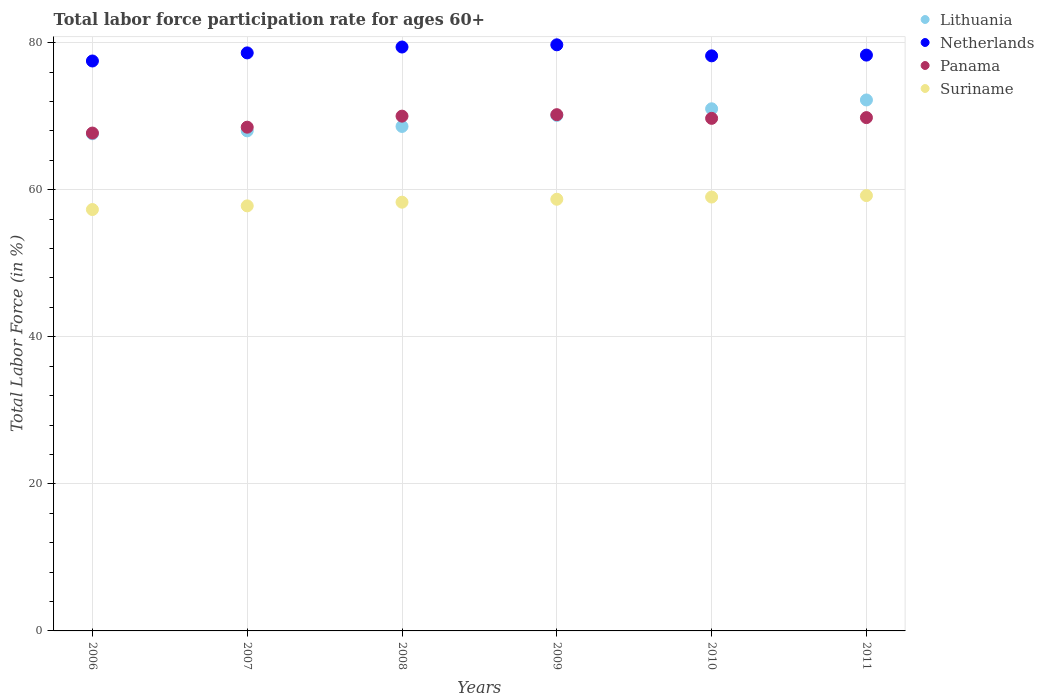How many different coloured dotlines are there?
Your response must be concise. 4. What is the labor force participation rate in Lithuania in 2008?
Offer a very short reply. 68.6. Across all years, what is the maximum labor force participation rate in Panama?
Provide a succinct answer. 70.2. Across all years, what is the minimum labor force participation rate in Lithuania?
Provide a succinct answer. 67.6. In which year was the labor force participation rate in Lithuania maximum?
Your response must be concise. 2011. What is the total labor force participation rate in Suriname in the graph?
Keep it short and to the point. 350.3. What is the difference between the labor force participation rate in Lithuania in 2006 and that in 2011?
Give a very brief answer. -4.6. What is the difference between the labor force participation rate in Panama in 2011 and the labor force participation rate in Netherlands in 2009?
Provide a succinct answer. -9.9. What is the average labor force participation rate in Lithuania per year?
Your answer should be compact. 69.58. In the year 2009, what is the difference between the labor force participation rate in Netherlands and labor force participation rate in Suriname?
Ensure brevity in your answer.  21. In how many years, is the labor force participation rate in Lithuania greater than 8 %?
Your answer should be very brief. 6. What is the ratio of the labor force participation rate in Lithuania in 2009 to that in 2011?
Give a very brief answer. 0.97. Is the labor force participation rate in Netherlands in 2007 less than that in 2009?
Your answer should be very brief. Yes. Is the difference between the labor force participation rate in Netherlands in 2007 and 2009 greater than the difference between the labor force participation rate in Suriname in 2007 and 2009?
Give a very brief answer. No. What is the difference between the highest and the second highest labor force participation rate in Suriname?
Make the answer very short. 0.2. What is the difference between the highest and the lowest labor force participation rate in Lithuania?
Offer a terse response. 4.6. In how many years, is the labor force participation rate in Netherlands greater than the average labor force participation rate in Netherlands taken over all years?
Make the answer very short. 2. Is it the case that in every year, the sum of the labor force participation rate in Netherlands and labor force participation rate in Lithuania  is greater than the labor force participation rate in Suriname?
Your answer should be very brief. Yes. Does the labor force participation rate in Suriname monotonically increase over the years?
Ensure brevity in your answer.  Yes. Is the labor force participation rate in Lithuania strictly less than the labor force participation rate in Suriname over the years?
Your answer should be compact. No. How many dotlines are there?
Make the answer very short. 4. How many legend labels are there?
Your response must be concise. 4. How are the legend labels stacked?
Give a very brief answer. Vertical. What is the title of the graph?
Keep it short and to the point. Total labor force participation rate for ages 60+. Does "Thailand" appear as one of the legend labels in the graph?
Offer a very short reply. No. What is the label or title of the Y-axis?
Make the answer very short. Total Labor Force (in %). What is the Total Labor Force (in %) in Lithuania in 2006?
Offer a terse response. 67.6. What is the Total Labor Force (in %) of Netherlands in 2006?
Your response must be concise. 77.5. What is the Total Labor Force (in %) of Panama in 2006?
Make the answer very short. 67.7. What is the Total Labor Force (in %) in Suriname in 2006?
Offer a terse response. 57.3. What is the Total Labor Force (in %) in Netherlands in 2007?
Offer a very short reply. 78.6. What is the Total Labor Force (in %) of Panama in 2007?
Offer a terse response. 68.5. What is the Total Labor Force (in %) in Suriname in 2007?
Ensure brevity in your answer.  57.8. What is the Total Labor Force (in %) in Lithuania in 2008?
Offer a very short reply. 68.6. What is the Total Labor Force (in %) in Netherlands in 2008?
Provide a short and direct response. 79.4. What is the Total Labor Force (in %) of Suriname in 2008?
Provide a succinct answer. 58.3. What is the Total Labor Force (in %) of Lithuania in 2009?
Your answer should be very brief. 70.1. What is the Total Labor Force (in %) in Netherlands in 2009?
Ensure brevity in your answer.  79.7. What is the Total Labor Force (in %) of Panama in 2009?
Provide a succinct answer. 70.2. What is the Total Labor Force (in %) in Suriname in 2009?
Keep it short and to the point. 58.7. What is the Total Labor Force (in %) in Lithuania in 2010?
Your answer should be very brief. 71. What is the Total Labor Force (in %) of Netherlands in 2010?
Provide a succinct answer. 78.2. What is the Total Labor Force (in %) of Panama in 2010?
Offer a very short reply. 69.7. What is the Total Labor Force (in %) in Suriname in 2010?
Your answer should be very brief. 59. What is the Total Labor Force (in %) in Lithuania in 2011?
Offer a terse response. 72.2. What is the Total Labor Force (in %) in Netherlands in 2011?
Give a very brief answer. 78.3. What is the Total Labor Force (in %) in Panama in 2011?
Your response must be concise. 69.8. What is the Total Labor Force (in %) of Suriname in 2011?
Offer a very short reply. 59.2. Across all years, what is the maximum Total Labor Force (in %) in Lithuania?
Keep it short and to the point. 72.2. Across all years, what is the maximum Total Labor Force (in %) of Netherlands?
Your answer should be compact. 79.7. Across all years, what is the maximum Total Labor Force (in %) in Panama?
Offer a very short reply. 70.2. Across all years, what is the maximum Total Labor Force (in %) of Suriname?
Keep it short and to the point. 59.2. Across all years, what is the minimum Total Labor Force (in %) of Lithuania?
Your response must be concise. 67.6. Across all years, what is the minimum Total Labor Force (in %) in Netherlands?
Provide a short and direct response. 77.5. Across all years, what is the minimum Total Labor Force (in %) in Panama?
Keep it short and to the point. 67.7. Across all years, what is the minimum Total Labor Force (in %) in Suriname?
Offer a terse response. 57.3. What is the total Total Labor Force (in %) of Lithuania in the graph?
Your response must be concise. 417.5. What is the total Total Labor Force (in %) of Netherlands in the graph?
Make the answer very short. 471.7. What is the total Total Labor Force (in %) of Panama in the graph?
Make the answer very short. 415.9. What is the total Total Labor Force (in %) in Suriname in the graph?
Keep it short and to the point. 350.3. What is the difference between the Total Labor Force (in %) of Lithuania in 2006 and that in 2007?
Give a very brief answer. -0.4. What is the difference between the Total Labor Force (in %) in Netherlands in 2006 and that in 2007?
Offer a very short reply. -1.1. What is the difference between the Total Labor Force (in %) of Panama in 2006 and that in 2007?
Offer a terse response. -0.8. What is the difference between the Total Labor Force (in %) of Lithuania in 2006 and that in 2008?
Provide a short and direct response. -1. What is the difference between the Total Labor Force (in %) of Netherlands in 2006 and that in 2008?
Give a very brief answer. -1.9. What is the difference between the Total Labor Force (in %) in Panama in 2006 and that in 2008?
Give a very brief answer. -2.3. What is the difference between the Total Labor Force (in %) in Lithuania in 2006 and that in 2009?
Offer a terse response. -2.5. What is the difference between the Total Labor Force (in %) in Panama in 2006 and that in 2010?
Keep it short and to the point. -2. What is the difference between the Total Labor Force (in %) of Lithuania in 2006 and that in 2011?
Your answer should be compact. -4.6. What is the difference between the Total Labor Force (in %) in Netherlands in 2006 and that in 2011?
Provide a succinct answer. -0.8. What is the difference between the Total Labor Force (in %) in Suriname in 2006 and that in 2011?
Make the answer very short. -1.9. What is the difference between the Total Labor Force (in %) in Netherlands in 2007 and that in 2008?
Provide a succinct answer. -0.8. What is the difference between the Total Labor Force (in %) of Lithuania in 2007 and that in 2009?
Ensure brevity in your answer.  -2.1. What is the difference between the Total Labor Force (in %) of Panama in 2007 and that in 2009?
Provide a short and direct response. -1.7. What is the difference between the Total Labor Force (in %) of Lithuania in 2007 and that in 2010?
Provide a succinct answer. -3. What is the difference between the Total Labor Force (in %) of Panama in 2007 and that in 2011?
Your answer should be very brief. -1.3. What is the difference between the Total Labor Force (in %) in Panama in 2008 and that in 2009?
Your answer should be compact. -0.2. What is the difference between the Total Labor Force (in %) of Suriname in 2008 and that in 2009?
Your answer should be very brief. -0.4. What is the difference between the Total Labor Force (in %) in Lithuania in 2008 and that in 2010?
Make the answer very short. -2.4. What is the difference between the Total Labor Force (in %) in Netherlands in 2008 and that in 2010?
Provide a succinct answer. 1.2. What is the difference between the Total Labor Force (in %) in Suriname in 2008 and that in 2010?
Ensure brevity in your answer.  -0.7. What is the difference between the Total Labor Force (in %) in Lithuania in 2008 and that in 2011?
Give a very brief answer. -3.6. What is the difference between the Total Labor Force (in %) in Netherlands in 2008 and that in 2011?
Offer a terse response. 1.1. What is the difference between the Total Labor Force (in %) in Panama in 2008 and that in 2011?
Give a very brief answer. 0.2. What is the difference between the Total Labor Force (in %) in Panama in 2009 and that in 2010?
Your answer should be very brief. 0.5. What is the difference between the Total Labor Force (in %) in Netherlands in 2009 and that in 2011?
Offer a terse response. 1.4. What is the difference between the Total Labor Force (in %) in Panama in 2009 and that in 2011?
Provide a succinct answer. 0.4. What is the difference between the Total Labor Force (in %) in Suriname in 2009 and that in 2011?
Provide a short and direct response. -0.5. What is the difference between the Total Labor Force (in %) of Lithuania in 2010 and that in 2011?
Make the answer very short. -1.2. What is the difference between the Total Labor Force (in %) in Panama in 2010 and that in 2011?
Ensure brevity in your answer.  -0.1. What is the difference between the Total Labor Force (in %) in Lithuania in 2006 and the Total Labor Force (in %) in Suriname in 2007?
Provide a succinct answer. 9.8. What is the difference between the Total Labor Force (in %) of Panama in 2006 and the Total Labor Force (in %) of Suriname in 2007?
Make the answer very short. 9.9. What is the difference between the Total Labor Force (in %) in Lithuania in 2006 and the Total Labor Force (in %) in Netherlands in 2008?
Your answer should be very brief. -11.8. What is the difference between the Total Labor Force (in %) in Panama in 2006 and the Total Labor Force (in %) in Suriname in 2008?
Keep it short and to the point. 9.4. What is the difference between the Total Labor Force (in %) of Lithuania in 2006 and the Total Labor Force (in %) of Netherlands in 2009?
Make the answer very short. -12.1. What is the difference between the Total Labor Force (in %) in Lithuania in 2006 and the Total Labor Force (in %) in Panama in 2009?
Offer a terse response. -2.6. What is the difference between the Total Labor Force (in %) of Lithuania in 2006 and the Total Labor Force (in %) of Suriname in 2009?
Ensure brevity in your answer.  8.9. What is the difference between the Total Labor Force (in %) in Panama in 2006 and the Total Labor Force (in %) in Suriname in 2009?
Your answer should be very brief. 9. What is the difference between the Total Labor Force (in %) in Lithuania in 2006 and the Total Labor Force (in %) in Panama in 2010?
Give a very brief answer. -2.1. What is the difference between the Total Labor Force (in %) in Netherlands in 2006 and the Total Labor Force (in %) in Panama in 2010?
Provide a short and direct response. 7.8. What is the difference between the Total Labor Force (in %) of Panama in 2006 and the Total Labor Force (in %) of Suriname in 2010?
Offer a terse response. 8.7. What is the difference between the Total Labor Force (in %) in Lithuania in 2006 and the Total Labor Force (in %) in Netherlands in 2011?
Offer a terse response. -10.7. What is the difference between the Total Labor Force (in %) in Lithuania in 2006 and the Total Labor Force (in %) in Panama in 2011?
Your response must be concise. -2.2. What is the difference between the Total Labor Force (in %) of Netherlands in 2006 and the Total Labor Force (in %) of Panama in 2011?
Your response must be concise. 7.7. What is the difference between the Total Labor Force (in %) of Panama in 2006 and the Total Labor Force (in %) of Suriname in 2011?
Your answer should be compact. 8.5. What is the difference between the Total Labor Force (in %) in Netherlands in 2007 and the Total Labor Force (in %) in Panama in 2008?
Make the answer very short. 8.6. What is the difference between the Total Labor Force (in %) in Netherlands in 2007 and the Total Labor Force (in %) in Suriname in 2008?
Keep it short and to the point. 20.3. What is the difference between the Total Labor Force (in %) of Lithuania in 2007 and the Total Labor Force (in %) of Panama in 2009?
Keep it short and to the point. -2.2. What is the difference between the Total Labor Force (in %) in Lithuania in 2007 and the Total Labor Force (in %) in Suriname in 2009?
Your response must be concise. 9.3. What is the difference between the Total Labor Force (in %) in Panama in 2007 and the Total Labor Force (in %) in Suriname in 2009?
Provide a succinct answer. 9.8. What is the difference between the Total Labor Force (in %) in Lithuania in 2007 and the Total Labor Force (in %) in Panama in 2010?
Offer a terse response. -1.7. What is the difference between the Total Labor Force (in %) in Netherlands in 2007 and the Total Labor Force (in %) in Suriname in 2010?
Give a very brief answer. 19.6. What is the difference between the Total Labor Force (in %) in Panama in 2007 and the Total Labor Force (in %) in Suriname in 2010?
Offer a very short reply. 9.5. What is the difference between the Total Labor Force (in %) in Lithuania in 2007 and the Total Labor Force (in %) in Netherlands in 2011?
Your answer should be compact. -10.3. What is the difference between the Total Labor Force (in %) of Lithuania in 2007 and the Total Labor Force (in %) of Panama in 2011?
Ensure brevity in your answer.  -1.8. What is the difference between the Total Labor Force (in %) of Lithuania in 2007 and the Total Labor Force (in %) of Suriname in 2011?
Give a very brief answer. 8.8. What is the difference between the Total Labor Force (in %) of Panama in 2007 and the Total Labor Force (in %) of Suriname in 2011?
Provide a short and direct response. 9.3. What is the difference between the Total Labor Force (in %) in Lithuania in 2008 and the Total Labor Force (in %) in Netherlands in 2009?
Make the answer very short. -11.1. What is the difference between the Total Labor Force (in %) in Netherlands in 2008 and the Total Labor Force (in %) in Panama in 2009?
Keep it short and to the point. 9.2. What is the difference between the Total Labor Force (in %) in Netherlands in 2008 and the Total Labor Force (in %) in Suriname in 2009?
Offer a very short reply. 20.7. What is the difference between the Total Labor Force (in %) in Panama in 2008 and the Total Labor Force (in %) in Suriname in 2009?
Offer a terse response. 11.3. What is the difference between the Total Labor Force (in %) in Lithuania in 2008 and the Total Labor Force (in %) in Panama in 2010?
Ensure brevity in your answer.  -1.1. What is the difference between the Total Labor Force (in %) of Lithuania in 2008 and the Total Labor Force (in %) of Suriname in 2010?
Offer a very short reply. 9.6. What is the difference between the Total Labor Force (in %) of Netherlands in 2008 and the Total Labor Force (in %) of Suriname in 2010?
Provide a short and direct response. 20.4. What is the difference between the Total Labor Force (in %) in Netherlands in 2008 and the Total Labor Force (in %) in Suriname in 2011?
Make the answer very short. 20.2. What is the difference between the Total Labor Force (in %) in Panama in 2008 and the Total Labor Force (in %) in Suriname in 2011?
Offer a terse response. 10.8. What is the difference between the Total Labor Force (in %) of Lithuania in 2009 and the Total Labor Force (in %) of Panama in 2010?
Offer a very short reply. 0.4. What is the difference between the Total Labor Force (in %) in Lithuania in 2009 and the Total Labor Force (in %) in Suriname in 2010?
Give a very brief answer. 11.1. What is the difference between the Total Labor Force (in %) of Netherlands in 2009 and the Total Labor Force (in %) of Panama in 2010?
Make the answer very short. 10. What is the difference between the Total Labor Force (in %) of Netherlands in 2009 and the Total Labor Force (in %) of Suriname in 2010?
Make the answer very short. 20.7. What is the difference between the Total Labor Force (in %) in Lithuania in 2009 and the Total Labor Force (in %) in Netherlands in 2011?
Ensure brevity in your answer.  -8.2. What is the difference between the Total Labor Force (in %) in Lithuania in 2010 and the Total Labor Force (in %) in Netherlands in 2011?
Keep it short and to the point. -7.3. What is the difference between the Total Labor Force (in %) in Lithuania in 2010 and the Total Labor Force (in %) in Panama in 2011?
Give a very brief answer. 1.2. What is the difference between the Total Labor Force (in %) in Netherlands in 2010 and the Total Labor Force (in %) in Panama in 2011?
Your answer should be very brief. 8.4. What is the difference between the Total Labor Force (in %) of Netherlands in 2010 and the Total Labor Force (in %) of Suriname in 2011?
Ensure brevity in your answer.  19. What is the difference between the Total Labor Force (in %) of Panama in 2010 and the Total Labor Force (in %) of Suriname in 2011?
Your response must be concise. 10.5. What is the average Total Labor Force (in %) of Lithuania per year?
Your response must be concise. 69.58. What is the average Total Labor Force (in %) in Netherlands per year?
Keep it short and to the point. 78.62. What is the average Total Labor Force (in %) of Panama per year?
Provide a short and direct response. 69.32. What is the average Total Labor Force (in %) in Suriname per year?
Provide a succinct answer. 58.38. In the year 2006, what is the difference between the Total Labor Force (in %) of Lithuania and Total Labor Force (in %) of Panama?
Offer a very short reply. -0.1. In the year 2006, what is the difference between the Total Labor Force (in %) of Lithuania and Total Labor Force (in %) of Suriname?
Provide a short and direct response. 10.3. In the year 2006, what is the difference between the Total Labor Force (in %) in Netherlands and Total Labor Force (in %) in Panama?
Your answer should be very brief. 9.8. In the year 2006, what is the difference between the Total Labor Force (in %) of Netherlands and Total Labor Force (in %) of Suriname?
Your answer should be very brief. 20.2. In the year 2007, what is the difference between the Total Labor Force (in %) in Lithuania and Total Labor Force (in %) in Netherlands?
Your answer should be compact. -10.6. In the year 2007, what is the difference between the Total Labor Force (in %) of Netherlands and Total Labor Force (in %) of Suriname?
Your answer should be very brief. 20.8. In the year 2007, what is the difference between the Total Labor Force (in %) of Panama and Total Labor Force (in %) of Suriname?
Give a very brief answer. 10.7. In the year 2008, what is the difference between the Total Labor Force (in %) in Lithuania and Total Labor Force (in %) in Netherlands?
Your response must be concise. -10.8. In the year 2008, what is the difference between the Total Labor Force (in %) of Netherlands and Total Labor Force (in %) of Suriname?
Provide a succinct answer. 21.1. In the year 2009, what is the difference between the Total Labor Force (in %) of Lithuania and Total Labor Force (in %) of Netherlands?
Provide a succinct answer. -9.6. In the year 2009, what is the difference between the Total Labor Force (in %) in Netherlands and Total Labor Force (in %) in Suriname?
Your response must be concise. 21. In the year 2010, what is the difference between the Total Labor Force (in %) of Lithuania and Total Labor Force (in %) of Suriname?
Offer a very short reply. 12. In the year 2010, what is the difference between the Total Labor Force (in %) in Netherlands and Total Labor Force (in %) in Panama?
Make the answer very short. 8.5. In the year 2010, what is the difference between the Total Labor Force (in %) of Panama and Total Labor Force (in %) of Suriname?
Make the answer very short. 10.7. In the year 2011, what is the difference between the Total Labor Force (in %) of Lithuania and Total Labor Force (in %) of Panama?
Provide a short and direct response. 2.4. In the year 2011, what is the difference between the Total Labor Force (in %) of Netherlands and Total Labor Force (in %) of Suriname?
Ensure brevity in your answer.  19.1. In the year 2011, what is the difference between the Total Labor Force (in %) in Panama and Total Labor Force (in %) in Suriname?
Provide a succinct answer. 10.6. What is the ratio of the Total Labor Force (in %) of Lithuania in 2006 to that in 2007?
Make the answer very short. 0.99. What is the ratio of the Total Labor Force (in %) of Netherlands in 2006 to that in 2007?
Provide a short and direct response. 0.99. What is the ratio of the Total Labor Force (in %) of Panama in 2006 to that in 2007?
Offer a very short reply. 0.99. What is the ratio of the Total Labor Force (in %) of Suriname in 2006 to that in 2007?
Provide a succinct answer. 0.99. What is the ratio of the Total Labor Force (in %) in Lithuania in 2006 to that in 2008?
Make the answer very short. 0.99. What is the ratio of the Total Labor Force (in %) of Netherlands in 2006 to that in 2008?
Offer a terse response. 0.98. What is the ratio of the Total Labor Force (in %) in Panama in 2006 to that in 2008?
Your answer should be compact. 0.97. What is the ratio of the Total Labor Force (in %) of Suriname in 2006 to that in 2008?
Keep it short and to the point. 0.98. What is the ratio of the Total Labor Force (in %) in Lithuania in 2006 to that in 2009?
Keep it short and to the point. 0.96. What is the ratio of the Total Labor Force (in %) of Netherlands in 2006 to that in 2009?
Keep it short and to the point. 0.97. What is the ratio of the Total Labor Force (in %) in Panama in 2006 to that in 2009?
Give a very brief answer. 0.96. What is the ratio of the Total Labor Force (in %) of Suriname in 2006 to that in 2009?
Offer a terse response. 0.98. What is the ratio of the Total Labor Force (in %) in Lithuania in 2006 to that in 2010?
Offer a terse response. 0.95. What is the ratio of the Total Labor Force (in %) of Netherlands in 2006 to that in 2010?
Provide a short and direct response. 0.99. What is the ratio of the Total Labor Force (in %) in Panama in 2006 to that in 2010?
Your response must be concise. 0.97. What is the ratio of the Total Labor Force (in %) of Suriname in 2006 to that in 2010?
Your response must be concise. 0.97. What is the ratio of the Total Labor Force (in %) in Lithuania in 2006 to that in 2011?
Provide a succinct answer. 0.94. What is the ratio of the Total Labor Force (in %) of Netherlands in 2006 to that in 2011?
Provide a succinct answer. 0.99. What is the ratio of the Total Labor Force (in %) in Panama in 2006 to that in 2011?
Give a very brief answer. 0.97. What is the ratio of the Total Labor Force (in %) in Suriname in 2006 to that in 2011?
Offer a terse response. 0.97. What is the ratio of the Total Labor Force (in %) of Netherlands in 2007 to that in 2008?
Offer a terse response. 0.99. What is the ratio of the Total Labor Force (in %) in Panama in 2007 to that in 2008?
Your answer should be very brief. 0.98. What is the ratio of the Total Labor Force (in %) of Suriname in 2007 to that in 2008?
Your answer should be compact. 0.99. What is the ratio of the Total Labor Force (in %) of Netherlands in 2007 to that in 2009?
Offer a very short reply. 0.99. What is the ratio of the Total Labor Force (in %) in Panama in 2007 to that in 2009?
Provide a short and direct response. 0.98. What is the ratio of the Total Labor Force (in %) of Suriname in 2007 to that in 2009?
Your answer should be compact. 0.98. What is the ratio of the Total Labor Force (in %) of Lithuania in 2007 to that in 2010?
Make the answer very short. 0.96. What is the ratio of the Total Labor Force (in %) of Panama in 2007 to that in 2010?
Give a very brief answer. 0.98. What is the ratio of the Total Labor Force (in %) of Suriname in 2007 to that in 2010?
Your response must be concise. 0.98. What is the ratio of the Total Labor Force (in %) of Lithuania in 2007 to that in 2011?
Offer a terse response. 0.94. What is the ratio of the Total Labor Force (in %) in Panama in 2007 to that in 2011?
Keep it short and to the point. 0.98. What is the ratio of the Total Labor Force (in %) in Suriname in 2007 to that in 2011?
Give a very brief answer. 0.98. What is the ratio of the Total Labor Force (in %) in Lithuania in 2008 to that in 2009?
Your answer should be compact. 0.98. What is the ratio of the Total Labor Force (in %) of Panama in 2008 to that in 2009?
Your response must be concise. 1. What is the ratio of the Total Labor Force (in %) in Lithuania in 2008 to that in 2010?
Provide a short and direct response. 0.97. What is the ratio of the Total Labor Force (in %) in Netherlands in 2008 to that in 2010?
Offer a very short reply. 1.02. What is the ratio of the Total Labor Force (in %) of Panama in 2008 to that in 2010?
Provide a short and direct response. 1. What is the ratio of the Total Labor Force (in %) of Suriname in 2008 to that in 2010?
Your response must be concise. 0.99. What is the ratio of the Total Labor Force (in %) in Lithuania in 2008 to that in 2011?
Your answer should be very brief. 0.95. What is the ratio of the Total Labor Force (in %) of Netherlands in 2008 to that in 2011?
Your answer should be compact. 1.01. What is the ratio of the Total Labor Force (in %) in Lithuania in 2009 to that in 2010?
Ensure brevity in your answer.  0.99. What is the ratio of the Total Labor Force (in %) of Netherlands in 2009 to that in 2010?
Ensure brevity in your answer.  1.02. What is the ratio of the Total Labor Force (in %) in Panama in 2009 to that in 2010?
Provide a short and direct response. 1.01. What is the ratio of the Total Labor Force (in %) of Suriname in 2009 to that in 2010?
Your answer should be very brief. 0.99. What is the ratio of the Total Labor Force (in %) of Lithuania in 2009 to that in 2011?
Keep it short and to the point. 0.97. What is the ratio of the Total Labor Force (in %) of Netherlands in 2009 to that in 2011?
Your response must be concise. 1.02. What is the ratio of the Total Labor Force (in %) in Panama in 2009 to that in 2011?
Keep it short and to the point. 1.01. What is the ratio of the Total Labor Force (in %) in Lithuania in 2010 to that in 2011?
Keep it short and to the point. 0.98. What is the ratio of the Total Labor Force (in %) of Netherlands in 2010 to that in 2011?
Your answer should be compact. 1. What is the ratio of the Total Labor Force (in %) of Panama in 2010 to that in 2011?
Your answer should be very brief. 1. What is the ratio of the Total Labor Force (in %) of Suriname in 2010 to that in 2011?
Your response must be concise. 1. What is the difference between the highest and the second highest Total Labor Force (in %) in Lithuania?
Give a very brief answer. 1.2. What is the difference between the highest and the second highest Total Labor Force (in %) of Netherlands?
Offer a very short reply. 0.3. What is the difference between the highest and the second highest Total Labor Force (in %) in Panama?
Your response must be concise. 0.2. What is the difference between the highest and the lowest Total Labor Force (in %) of Lithuania?
Offer a terse response. 4.6. What is the difference between the highest and the lowest Total Labor Force (in %) of Suriname?
Offer a terse response. 1.9. 